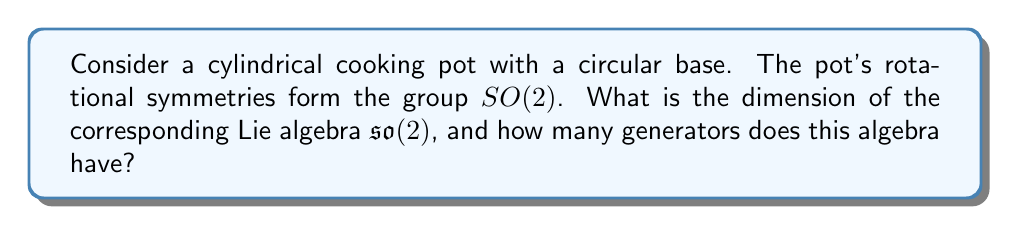Can you solve this math problem? To solve this problem, let's approach it step-by-step:

1) The group $SO(2)$ represents all rotations in a 2-dimensional plane. For a cylindrical pot, these rotations are around its central axis.

2) The Lie algebra $\mathfrak{so}(2)$ is associated with the Lie group $SO(2)$. It represents the infinitesimal rotations or the tangent space at the identity of $SO(2)$.

3) To find the dimension of $\mathfrak{so}(2)$, we need to consider the general form of a rotation matrix in 2D:

   $$R(\theta) = \begin{pmatrix} \cos\theta & -\sin\theta \\ \sin\theta & \cos\theta \end{pmatrix}$$

4) The infinitesimal generator of this rotation is found by differentiating $R(\theta)$ with respect to $\theta$ at $\theta = 0$:

   $$\frac{d}{d\theta}R(\theta)\bigg|_{\theta=0} = \begin{pmatrix} 0 & -1 \\ 1 & 0 \end{pmatrix}$$

5) This single matrix generates all rotations in 2D. Therefore, $\mathfrak{so}(2)$ is spanned by one basis element, which we can represent as:

   $$J = \begin{pmatrix} 0 & -1 \\ 1 & 0 \end{pmatrix}$$

6) The dimension of a Lie algebra is equal to the number of its generators. In this case, we have one generator, so the dimension is 1.

Therefore, the Lie algebra $\mathfrak{so}(2)$ associated with the rotational symmetries of a cylindrical cooking pot has dimension 1 and is generated by a single element.
Answer: Dimension: 1; Generators: 1 